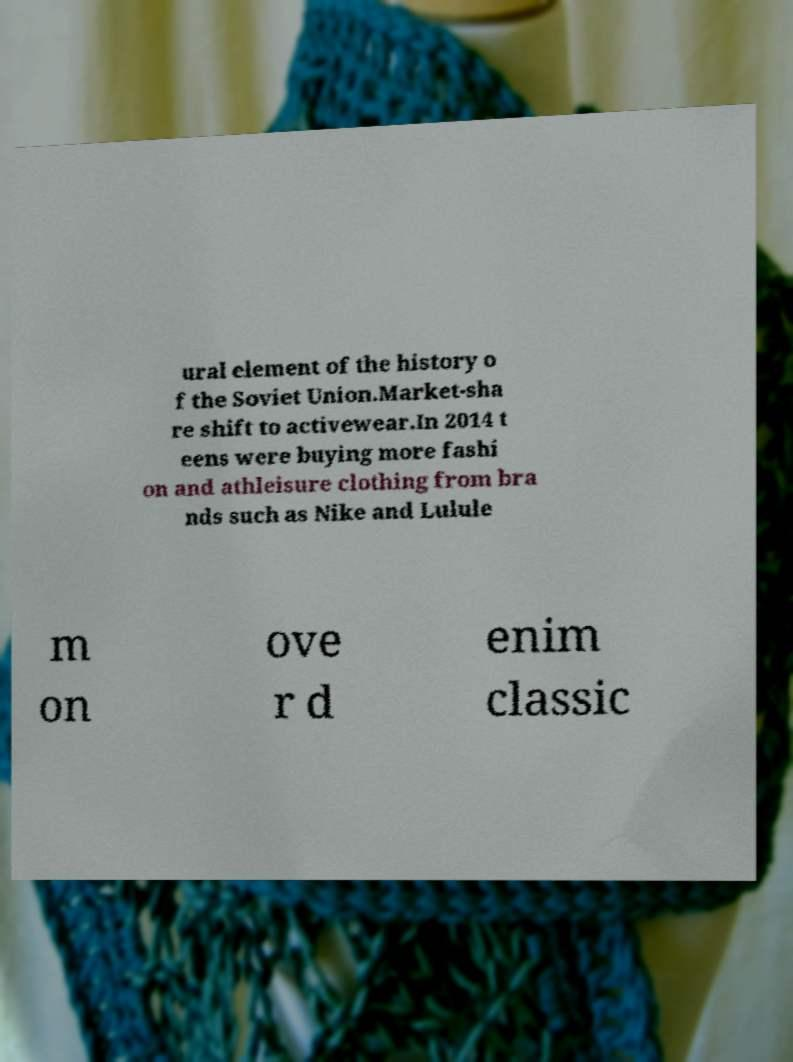Could you extract and type out the text from this image? ural element of the history o f the Soviet Union.Market-sha re shift to activewear.In 2014 t eens were buying more fashi on and athleisure clothing from bra nds such as Nike and Lulule m on ove r d enim classic 